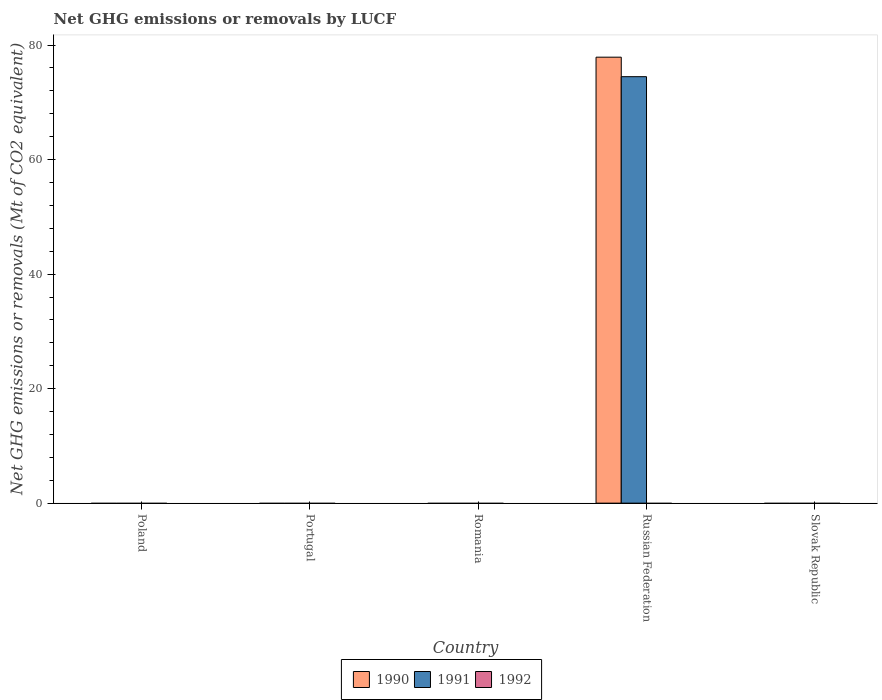Are the number of bars on each tick of the X-axis equal?
Provide a succinct answer. No. How many bars are there on the 4th tick from the left?
Make the answer very short. 2. What is the label of the 1st group of bars from the left?
Provide a short and direct response. Poland. What is the net GHG emissions or removals by LUCF in 1991 in Russian Federation?
Your response must be concise. 74.48. Across all countries, what is the maximum net GHG emissions or removals by LUCF in 1991?
Your response must be concise. 74.48. In which country was the net GHG emissions or removals by LUCF in 1990 maximum?
Keep it short and to the point. Russian Federation. What is the total net GHG emissions or removals by LUCF in 1990 in the graph?
Offer a terse response. 77.88. What is the difference between the net GHG emissions or removals by LUCF in 1991 in Russian Federation and the net GHG emissions or removals by LUCF in 1990 in Slovak Republic?
Keep it short and to the point. 74.48. What is the average net GHG emissions or removals by LUCF in 1990 per country?
Give a very brief answer. 15.58. What is the difference between the net GHG emissions or removals by LUCF of/in 1991 and net GHG emissions or removals by LUCF of/in 1990 in Russian Federation?
Offer a terse response. -3.41. In how many countries, is the net GHG emissions or removals by LUCF in 1990 greater than 56 Mt?
Provide a short and direct response. 1. What is the difference between the highest and the lowest net GHG emissions or removals by LUCF in 1990?
Keep it short and to the point. 77.88. In how many countries, is the net GHG emissions or removals by LUCF in 1991 greater than the average net GHG emissions or removals by LUCF in 1991 taken over all countries?
Give a very brief answer. 1. Is it the case that in every country, the sum of the net GHG emissions or removals by LUCF in 1991 and net GHG emissions or removals by LUCF in 1992 is greater than the net GHG emissions or removals by LUCF in 1990?
Your answer should be very brief. No. How many bars are there?
Keep it short and to the point. 2. What is the difference between two consecutive major ticks on the Y-axis?
Your answer should be compact. 20. Does the graph contain grids?
Give a very brief answer. No. How are the legend labels stacked?
Offer a very short reply. Horizontal. What is the title of the graph?
Offer a terse response. Net GHG emissions or removals by LUCF. What is the label or title of the Y-axis?
Offer a very short reply. Net GHG emissions or removals (Mt of CO2 equivalent). What is the Net GHG emissions or removals (Mt of CO2 equivalent) in 1992 in Poland?
Offer a terse response. 0. What is the Net GHG emissions or removals (Mt of CO2 equivalent) in 1990 in Portugal?
Provide a succinct answer. 0. What is the Net GHG emissions or removals (Mt of CO2 equivalent) in 1991 in Portugal?
Make the answer very short. 0. What is the Net GHG emissions or removals (Mt of CO2 equivalent) of 1992 in Portugal?
Your answer should be very brief. 0. What is the Net GHG emissions or removals (Mt of CO2 equivalent) of 1990 in Romania?
Your answer should be very brief. 0. What is the Net GHG emissions or removals (Mt of CO2 equivalent) in 1991 in Romania?
Your response must be concise. 0. What is the Net GHG emissions or removals (Mt of CO2 equivalent) of 1992 in Romania?
Your answer should be very brief. 0. What is the Net GHG emissions or removals (Mt of CO2 equivalent) of 1990 in Russian Federation?
Keep it short and to the point. 77.88. What is the Net GHG emissions or removals (Mt of CO2 equivalent) of 1991 in Russian Federation?
Provide a succinct answer. 74.48. What is the Net GHG emissions or removals (Mt of CO2 equivalent) of 1991 in Slovak Republic?
Offer a terse response. 0. What is the Net GHG emissions or removals (Mt of CO2 equivalent) of 1992 in Slovak Republic?
Give a very brief answer. 0. Across all countries, what is the maximum Net GHG emissions or removals (Mt of CO2 equivalent) in 1990?
Your answer should be compact. 77.88. Across all countries, what is the maximum Net GHG emissions or removals (Mt of CO2 equivalent) in 1991?
Offer a terse response. 74.48. Across all countries, what is the minimum Net GHG emissions or removals (Mt of CO2 equivalent) of 1991?
Provide a succinct answer. 0. What is the total Net GHG emissions or removals (Mt of CO2 equivalent) of 1990 in the graph?
Your answer should be very brief. 77.89. What is the total Net GHG emissions or removals (Mt of CO2 equivalent) of 1991 in the graph?
Offer a very short reply. 74.48. What is the average Net GHG emissions or removals (Mt of CO2 equivalent) of 1990 per country?
Give a very brief answer. 15.58. What is the average Net GHG emissions or removals (Mt of CO2 equivalent) in 1991 per country?
Provide a succinct answer. 14.9. What is the average Net GHG emissions or removals (Mt of CO2 equivalent) in 1992 per country?
Make the answer very short. 0. What is the difference between the Net GHG emissions or removals (Mt of CO2 equivalent) of 1990 and Net GHG emissions or removals (Mt of CO2 equivalent) of 1991 in Russian Federation?
Give a very brief answer. 3.41. What is the difference between the highest and the lowest Net GHG emissions or removals (Mt of CO2 equivalent) in 1990?
Offer a terse response. 77.89. What is the difference between the highest and the lowest Net GHG emissions or removals (Mt of CO2 equivalent) of 1991?
Provide a short and direct response. 74.48. 